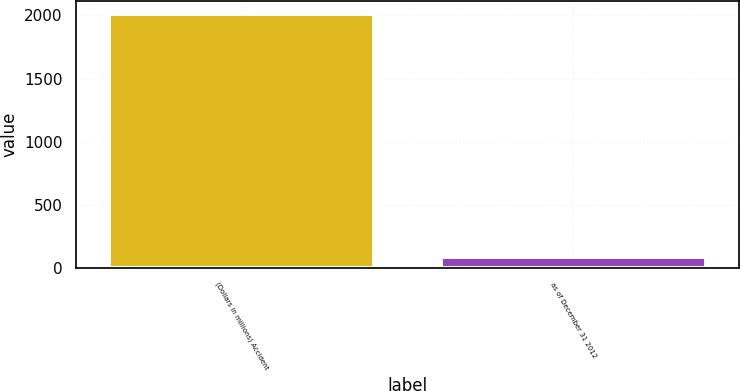<chart> <loc_0><loc_0><loc_500><loc_500><bar_chart><fcel>(Dollars in millions) Accident<fcel>as of December 31 2012<nl><fcel>2012<fcel>86.6<nl></chart> 